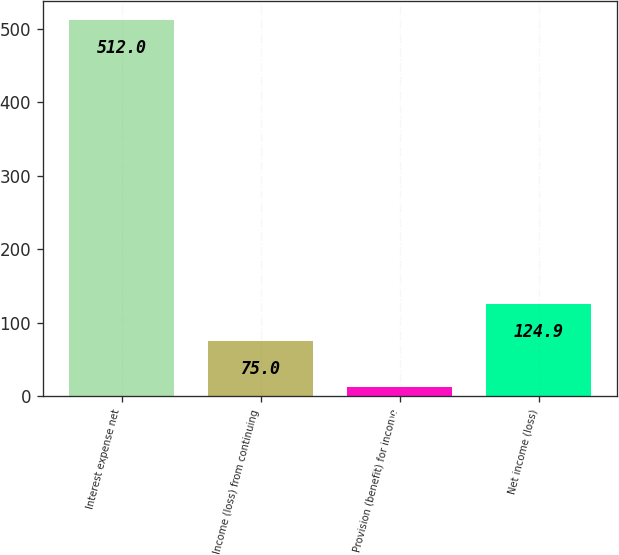Convert chart. <chart><loc_0><loc_0><loc_500><loc_500><bar_chart><fcel>Interest expense net<fcel>Income (loss) from continuing<fcel>Provision (benefit) for income<fcel>Net income (loss)<nl><fcel>512<fcel>75<fcel>13<fcel>124.9<nl></chart> 